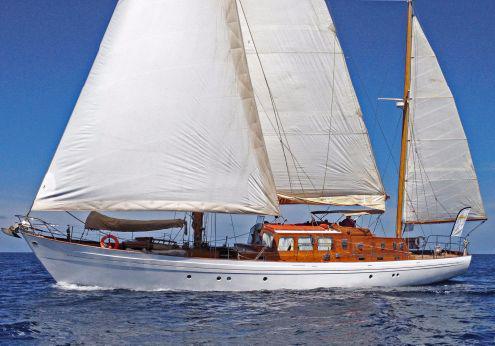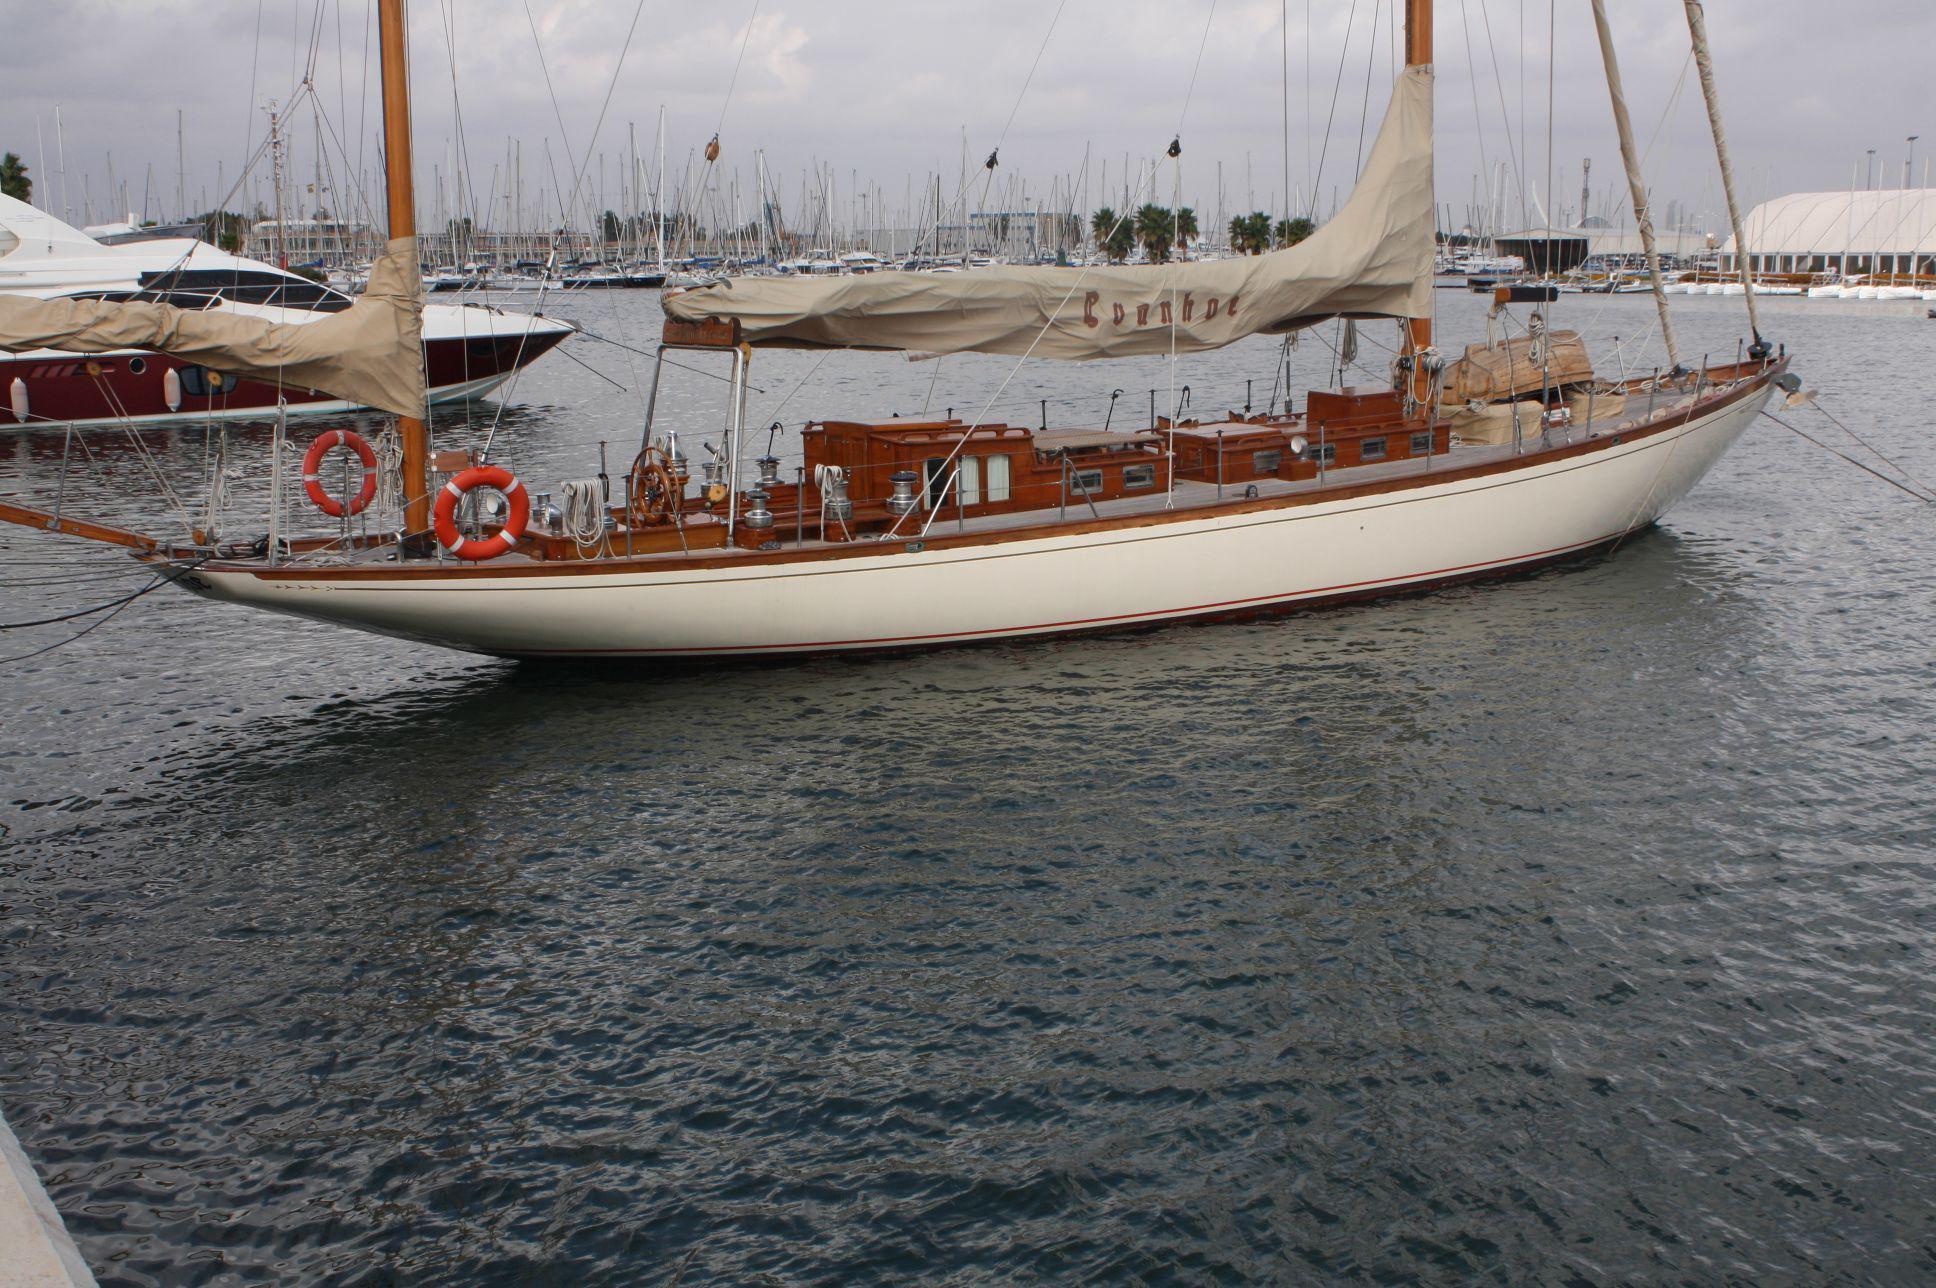The first image is the image on the left, the second image is the image on the right. For the images displayed, is the sentence "The image on the left has a boat with at least three of its sails engaged." factually correct? Answer yes or no. Yes. The first image is the image on the left, the second image is the image on the right. Given the left and right images, does the statement "There is a sailboat going left with at least two passengers in the boat." hold true? Answer yes or no. No. 